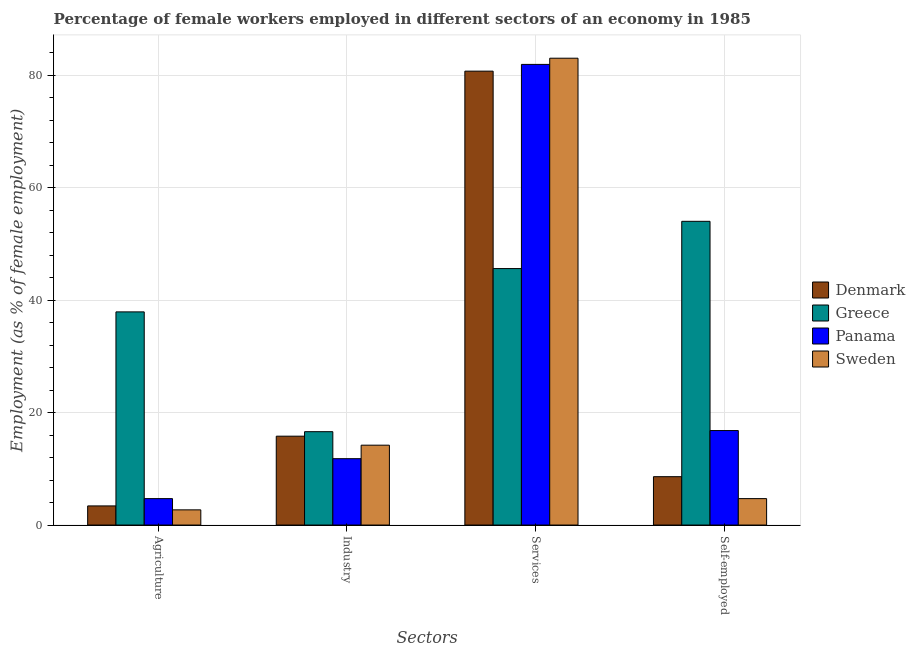Are the number of bars per tick equal to the number of legend labels?
Offer a very short reply. Yes. How many bars are there on the 3rd tick from the left?
Your response must be concise. 4. What is the label of the 4th group of bars from the left?
Make the answer very short. Self-employed. What is the percentage of female workers in services in Greece?
Keep it short and to the point. 45.6. Across all countries, what is the maximum percentage of female workers in industry?
Ensure brevity in your answer.  16.6. Across all countries, what is the minimum percentage of female workers in industry?
Offer a very short reply. 11.8. In which country was the percentage of self employed female workers minimum?
Provide a succinct answer. Sweden. What is the total percentage of female workers in industry in the graph?
Give a very brief answer. 58.4. What is the difference between the percentage of female workers in agriculture in Greece and that in Sweden?
Provide a succinct answer. 35.2. What is the difference between the percentage of self employed female workers in Greece and the percentage of female workers in industry in Denmark?
Offer a terse response. 38.2. What is the average percentage of female workers in industry per country?
Keep it short and to the point. 14.6. What is the difference between the percentage of female workers in services and percentage of female workers in industry in Panama?
Offer a terse response. 70.1. In how many countries, is the percentage of self employed female workers greater than 76 %?
Provide a short and direct response. 0. What is the ratio of the percentage of female workers in industry in Denmark to that in Greece?
Provide a succinct answer. 0.95. Is the difference between the percentage of female workers in services in Sweden and Greece greater than the difference between the percentage of female workers in agriculture in Sweden and Greece?
Give a very brief answer. Yes. What is the difference between the highest and the second highest percentage of female workers in industry?
Ensure brevity in your answer.  0.8. What is the difference between the highest and the lowest percentage of female workers in services?
Your answer should be compact. 37.4. In how many countries, is the percentage of self employed female workers greater than the average percentage of self employed female workers taken over all countries?
Offer a very short reply. 1. What does the 3rd bar from the left in Services represents?
Ensure brevity in your answer.  Panama. What does the 2nd bar from the right in Industry represents?
Offer a very short reply. Panama. Are all the bars in the graph horizontal?
Your answer should be compact. No. What is the difference between two consecutive major ticks on the Y-axis?
Your answer should be very brief. 20. Are the values on the major ticks of Y-axis written in scientific E-notation?
Provide a short and direct response. No. Does the graph contain any zero values?
Your response must be concise. No. What is the title of the graph?
Provide a succinct answer. Percentage of female workers employed in different sectors of an economy in 1985. What is the label or title of the X-axis?
Your answer should be very brief. Sectors. What is the label or title of the Y-axis?
Your answer should be compact. Employment (as % of female employment). What is the Employment (as % of female employment) of Denmark in Agriculture?
Your response must be concise. 3.4. What is the Employment (as % of female employment) of Greece in Agriculture?
Your answer should be compact. 37.9. What is the Employment (as % of female employment) in Panama in Agriculture?
Offer a very short reply. 4.7. What is the Employment (as % of female employment) of Sweden in Agriculture?
Your answer should be compact. 2.7. What is the Employment (as % of female employment) of Denmark in Industry?
Ensure brevity in your answer.  15.8. What is the Employment (as % of female employment) in Greece in Industry?
Your response must be concise. 16.6. What is the Employment (as % of female employment) in Panama in Industry?
Provide a succinct answer. 11.8. What is the Employment (as % of female employment) in Sweden in Industry?
Provide a succinct answer. 14.2. What is the Employment (as % of female employment) of Denmark in Services?
Your answer should be compact. 80.7. What is the Employment (as % of female employment) of Greece in Services?
Give a very brief answer. 45.6. What is the Employment (as % of female employment) of Panama in Services?
Keep it short and to the point. 81.9. What is the Employment (as % of female employment) of Sweden in Services?
Provide a short and direct response. 83. What is the Employment (as % of female employment) in Denmark in Self-employed?
Offer a very short reply. 8.6. What is the Employment (as % of female employment) of Panama in Self-employed?
Give a very brief answer. 16.8. What is the Employment (as % of female employment) in Sweden in Self-employed?
Offer a very short reply. 4.7. Across all Sectors, what is the maximum Employment (as % of female employment) of Denmark?
Provide a short and direct response. 80.7. Across all Sectors, what is the maximum Employment (as % of female employment) of Greece?
Offer a very short reply. 54. Across all Sectors, what is the maximum Employment (as % of female employment) in Panama?
Make the answer very short. 81.9. Across all Sectors, what is the maximum Employment (as % of female employment) in Sweden?
Offer a very short reply. 83. Across all Sectors, what is the minimum Employment (as % of female employment) in Denmark?
Offer a very short reply. 3.4. Across all Sectors, what is the minimum Employment (as % of female employment) of Greece?
Give a very brief answer. 16.6. Across all Sectors, what is the minimum Employment (as % of female employment) in Panama?
Offer a very short reply. 4.7. Across all Sectors, what is the minimum Employment (as % of female employment) of Sweden?
Offer a terse response. 2.7. What is the total Employment (as % of female employment) of Denmark in the graph?
Your response must be concise. 108.5. What is the total Employment (as % of female employment) in Greece in the graph?
Make the answer very short. 154.1. What is the total Employment (as % of female employment) in Panama in the graph?
Keep it short and to the point. 115.2. What is the total Employment (as % of female employment) in Sweden in the graph?
Give a very brief answer. 104.6. What is the difference between the Employment (as % of female employment) in Greece in Agriculture and that in Industry?
Give a very brief answer. 21.3. What is the difference between the Employment (as % of female employment) in Sweden in Agriculture and that in Industry?
Make the answer very short. -11.5. What is the difference between the Employment (as % of female employment) in Denmark in Agriculture and that in Services?
Your answer should be compact. -77.3. What is the difference between the Employment (as % of female employment) of Panama in Agriculture and that in Services?
Your answer should be very brief. -77.2. What is the difference between the Employment (as % of female employment) of Sweden in Agriculture and that in Services?
Make the answer very short. -80.3. What is the difference between the Employment (as % of female employment) in Denmark in Agriculture and that in Self-employed?
Give a very brief answer. -5.2. What is the difference between the Employment (as % of female employment) of Greece in Agriculture and that in Self-employed?
Make the answer very short. -16.1. What is the difference between the Employment (as % of female employment) of Sweden in Agriculture and that in Self-employed?
Keep it short and to the point. -2. What is the difference between the Employment (as % of female employment) in Denmark in Industry and that in Services?
Ensure brevity in your answer.  -64.9. What is the difference between the Employment (as % of female employment) in Panama in Industry and that in Services?
Offer a terse response. -70.1. What is the difference between the Employment (as % of female employment) in Sweden in Industry and that in Services?
Your answer should be compact. -68.8. What is the difference between the Employment (as % of female employment) in Denmark in Industry and that in Self-employed?
Provide a short and direct response. 7.2. What is the difference between the Employment (as % of female employment) of Greece in Industry and that in Self-employed?
Make the answer very short. -37.4. What is the difference between the Employment (as % of female employment) of Sweden in Industry and that in Self-employed?
Ensure brevity in your answer.  9.5. What is the difference between the Employment (as % of female employment) in Denmark in Services and that in Self-employed?
Offer a very short reply. 72.1. What is the difference between the Employment (as % of female employment) in Greece in Services and that in Self-employed?
Offer a very short reply. -8.4. What is the difference between the Employment (as % of female employment) in Panama in Services and that in Self-employed?
Ensure brevity in your answer.  65.1. What is the difference between the Employment (as % of female employment) in Sweden in Services and that in Self-employed?
Provide a short and direct response. 78.3. What is the difference between the Employment (as % of female employment) in Denmark in Agriculture and the Employment (as % of female employment) in Panama in Industry?
Provide a short and direct response. -8.4. What is the difference between the Employment (as % of female employment) of Greece in Agriculture and the Employment (as % of female employment) of Panama in Industry?
Give a very brief answer. 26.1. What is the difference between the Employment (as % of female employment) of Greece in Agriculture and the Employment (as % of female employment) of Sweden in Industry?
Ensure brevity in your answer.  23.7. What is the difference between the Employment (as % of female employment) in Panama in Agriculture and the Employment (as % of female employment) in Sweden in Industry?
Ensure brevity in your answer.  -9.5. What is the difference between the Employment (as % of female employment) in Denmark in Agriculture and the Employment (as % of female employment) in Greece in Services?
Keep it short and to the point. -42.2. What is the difference between the Employment (as % of female employment) in Denmark in Agriculture and the Employment (as % of female employment) in Panama in Services?
Keep it short and to the point. -78.5. What is the difference between the Employment (as % of female employment) of Denmark in Agriculture and the Employment (as % of female employment) of Sweden in Services?
Your response must be concise. -79.6. What is the difference between the Employment (as % of female employment) of Greece in Agriculture and the Employment (as % of female employment) of Panama in Services?
Your answer should be very brief. -44. What is the difference between the Employment (as % of female employment) of Greece in Agriculture and the Employment (as % of female employment) of Sweden in Services?
Ensure brevity in your answer.  -45.1. What is the difference between the Employment (as % of female employment) of Panama in Agriculture and the Employment (as % of female employment) of Sweden in Services?
Ensure brevity in your answer.  -78.3. What is the difference between the Employment (as % of female employment) of Denmark in Agriculture and the Employment (as % of female employment) of Greece in Self-employed?
Give a very brief answer. -50.6. What is the difference between the Employment (as % of female employment) in Denmark in Agriculture and the Employment (as % of female employment) in Panama in Self-employed?
Ensure brevity in your answer.  -13.4. What is the difference between the Employment (as % of female employment) in Denmark in Agriculture and the Employment (as % of female employment) in Sweden in Self-employed?
Offer a terse response. -1.3. What is the difference between the Employment (as % of female employment) in Greece in Agriculture and the Employment (as % of female employment) in Panama in Self-employed?
Offer a terse response. 21.1. What is the difference between the Employment (as % of female employment) in Greece in Agriculture and the Employment (as % of female employment) in Sweden in Self-employed?
Offer a terse response. 33.2. What is the difference between the Employment (as % of female employment) in Panama in Agriculture and the Employment (as % of female employment) in Sweden in Self-employed?
Offer a very short reply. 0. What is the difference between the Employment (as % of female employment) of Denmark in Industry and the Employment (as % of female employment) of Greece in Services?
Make the answer very short. -29.8. What is the difference between the Employment (as % of female employment) of Denmark in Industry and the Employment (as % of female employment) of Panama in Services?
Provide a succinct answer. -66.1. What is the difference between the Employment (as % of female employment) of Denmark in Industry and the Employment (as % of female employment) of Sweden in Services?
Provide a succinct answer. -67.2. What is the difference between the Employment (as % of female employment) of Greece in Industry and the Employment (as % of female employment) of Panama in Services?
Provide a short and direct response. -65.3. What is the difference between the Employment (as % of female employment) of Greece in Industry and the Employment (as % of female employment) of Sweden in Services?
Your answer should be compact. -66.4. What is the difference between the Employment (as % of female employment) in Panama in Industry and the Employment (as % of female employment) in Sweden in Services?
Your answer should be compact. -71.2. What is the difference between the Employment (as % of female employment) of Denmark in Industry and the Employment (as % of female employment) of Greece in Self-employed?
Your response must be concise. -38.2. What is the difference between the Employment (as % of female employment) in Denmark in Industry and the Employment (as % of female employment) in Sweden in Self-employed?
Offer a very short reply. 11.1. What is the difference between the Employment (as % of female employment) in Greece in Industry and the Employment (as % of female employment) in Panama in Self-employed?
Offer a very short reply. -0.2. What is the difference between the Employment (as % of female employment) of Panama in Industry and the Employment (as % of female employment) of Sweden in Self-employed?
Keep it short and to the point. 7.1. What is the difference between the Employment (as % of female employment) in Denmark in Services and the Employment (as % of female employment) in Greece in Self-employed?
Keep it short and to the point. 26.7. What is the difference between the Employment (as % of female employment) in Denmark in Services and the Employment (as % of female employment) in Panama in Self-employed?
Offer a terse response. 63.9. What is the difference between the Employment (as % of female employment) of Greece in Services and the Employment (as % of female employment) of Panama in Self-employed?
Your answer should be very brief. 28.8. What is the difference between the Employment (as % of female employment) of Greece in Services and the Employment (as % of female employment) of Sweden in Self-employed?
Ensure brevity in your answer.  40.9. What is the difference between the Employment (as % of female employment) in Panama in Services and the Employment (as % of female employment) in Sweden in Self-employed?
Offer a very short reply. 77.2. What is the average Employment (as % of female employment) in Denmark per Sectors?
Provide a succinct answer. 27.12. What is the average Employment (as % of female employment) of Greece per Sectors?
Your response must be concise. 38.52. What is the average Employment (as % of female employment) of Panama per Sectors?
Provide a succinct answer. 28.8. What is the average Employment (as % of female employment) in Sweden per Sectors?
Make the answer very short. 26.15. What is the difference between the Employment (as % of female employment) of Denmark and Employment (as % of female employment) of Greece in Agriculture?
Keep it short and to the point. -34.5. What is the difference between the Employment (as % of female employment) of Denmark and Employment (as % of female employment) of Panama in Agriculture?
Provide a short and direct response. -1.3. What is the difference between the Employment (as % of female employment) in Greece and Employment (as % of female employment) in Panama in Agriculture?
Your answer should be compact. 33.2. What is the difference between the Employment (as % of female employment) of Greece and Employment (as % of female employment) of Sweden in Agriculture?
Keep it short and to the point. 35.2. What is the difference between the Employment (as % of female employment) in Panama and Employment (as % of female employment) in Sweden in Agriculture?
Your answer should be compact. 2. What is the difference between the Employment (as % of female employment) of Denmark and Employment (as % of female employment) of Sweden in Industry?
Ensure brevity in your answer.  1.6. What is the difference between the Employment (as % of female employment) in Greece and Employment (as % of female employment) in Panama in Industry?
Keep it short and to the point. 4.8. What is the difference between the Employment (as % of female employment) of Greece and Employment (as % of female employment) of Sweden in Industry?
Offer a very short reply. 2.4. What is the difference between the Employment (as % of female employment) in Denmark and Employment (as % of female employment) in Greece in Services?
Provide a succinct answer. 35.1. What is the difference between the Employment (as % of female employment) of Denmark and Employment (as % of female employment) of Panama in Services?
Provide a succinct answer. -1.2. What is the difference between the Employment (as % of female employment) in Denmark and Employment (as % of female employment) in Sweden in Services?
Provide a succinct answer. -2.3. What is the difference between the Employment (as % of female employment) of Greece and Employment (as % of female employment) of Panama in Services?
Make the answer very short. -36.3. What is the difference between the Employment (as % of female employment) in Greece and Employment (as % of female employment) in Sweden in Services?
Ensure brevity in your answer.  -37.4. What is the difference between the Employment (as % of female employment) of Denmark and Employment (as % of female employment) of Greece in Self-employed?
Ensure brevity in your answer.  -45.4. What is the difference between the Employment (as % of female employment) in Denmark and Employment (as % of female employment) in Panama in Self-employed?
Provide a succinct answer. -8.2. What is the difference between the Employment (as % of female employment) of Greece and Employment (as % of female employment) of Panama in Self-employed?
Your response must be concise. 37.2. What is the difference between the Employment (as % of female employment) in Greece and Employment (as % of female employment) in Sweden in Self-employed?
Offer a terse response. 49.3. What is the ratio of the Employment (as % of female employment) in Denmark in Agriculture to that in Industry?
Offer a very short reply. 0.22. What is the ratio of the Employment (as % of female employment) in Greece in Agriculture to that in Industry?
Your answer should be very brief. 2.28. What is the ratio of the Employment (as % of female employment) of Panama in Agriculture to that in Industry?
Provide a succinct answer. 0.4. What is the ratio of the Employment (as % of female employment) in Sweden in Agriculture to that in Industry?
Keep it short and to the point. 0.19. What is the ratio of the Employment (as % of female employment) in Denmark in Agriculture to that in Services?
Offer a very short reply. 0.04. What is the ratio of the Employment (as % of female employment) in Greece in Agriculture to that in Services?
Give a very brief answer. 0.83. What is the ratio of the Employment (as % of female employment) of Panama in Agriculture to that in Services?
Provide a short and direct response. 0.06. What is the ratio of the Employment (as % of female employment) in Sweden in Agriculture to that in Services?
Ensure brevity in your answer.  0.03. What is the ratio of the Employment (as % of female employment) in Denmark in Agriculture to that in Self-employed?
Ensure brevity in your answer.  0.4. What is the ratio of the Employment (as % of female employment) in Greece in Agriculture to that in Self-employed?
Provide a succinct answer. 0.7. What is the ratio of the Employment (as % of female employment) in Panama in Agriculture to that in Self-employed?
Provide a succinct answer. 0.28. What is the ratio of the Employment (as % of female employment) of Sweden in Agriculture to that in Self-employed?
Offer a terse response. 0.57. What is the ratio of the Employment (as % of female employment) in Denmark in Industry to that in Services?
Provide a succinct answer. 0.2. What is the ratio of the Employment (as % of female employment) of Greece in Industry to that in Services?
Keep it short and to the point. 0.36. What is the ratio of the Employment (as % of female employment) in Panama in Industry to that in Services?
Provide a succinct answer. 0.14. What is the ratio of the Employment (as % of female employment) in Sweden in Industry to that in Services?
Offer a very short reply. 0.17. What is the ratio of the Employment (as % of female employment) of Denmark in Industry to that in Self-employed?
Your answer should be very brief. 1.84. What is the ratio of the Employment (as % of female employment) of Greece in Industry to that in Self-employed?
Offer a very short reply. 0.31. What is the ratio of the Employment (as % of female employment) of Panama in Industry to that in Self-employed?
Keep it short and to the point. 0.7. What is the ratio of the Employment (as % of female employment) in Sweden in Industry to that in Self-employed?
Offer a terse response. 3.02. What is the ratio of the Employment (as % of female employment) in Denmark in Services to that in Self-employed?
Ensure brevity in your answer.  9.38. What is the ratio of the Employment (as % of female employment) of Greece in Services to that in Self-employed?
Offer a very short reply. 0.84. What is the ratio of the Employment (as % of female employment) in Panama in Services to that in Self-employed?
Provide a short and direct response. 4.88. What is the ratio of the Employment (as % of female employment) in Sweden in Services to that in Self-employed?
Make the answer very short. 17.66. What is the difference between the highest and the second highest Employment (as % of female employment) of Denmark?
Provide a short and direct response. 64.9. What is the difference between the highest and the second highest Employment (as % of female employment) in Panama?
Keep it short and to the point. 65.1. What is the difference between the highest and the second highest Employment (as % of female employment) of Sweden?
Give a very brief answer. 68.8. What is the difference between the highest and the lowest Employment (as % of female employment) in Denmark?
Provide a short and direct response. 77.3. What is the difference between the highest and the lowest Employment (as % of female employment) in Greece?
Your answer should be very brief. 37.4. What is the difference between the highest and the lowest Employment (as % of female employment) of Panama?
Provide a short and direct response. 77.2. What is the difference between the highest and the lowest Employment (as % of female employment) in Sweden?
Provide a succinct answer. 80.3. 